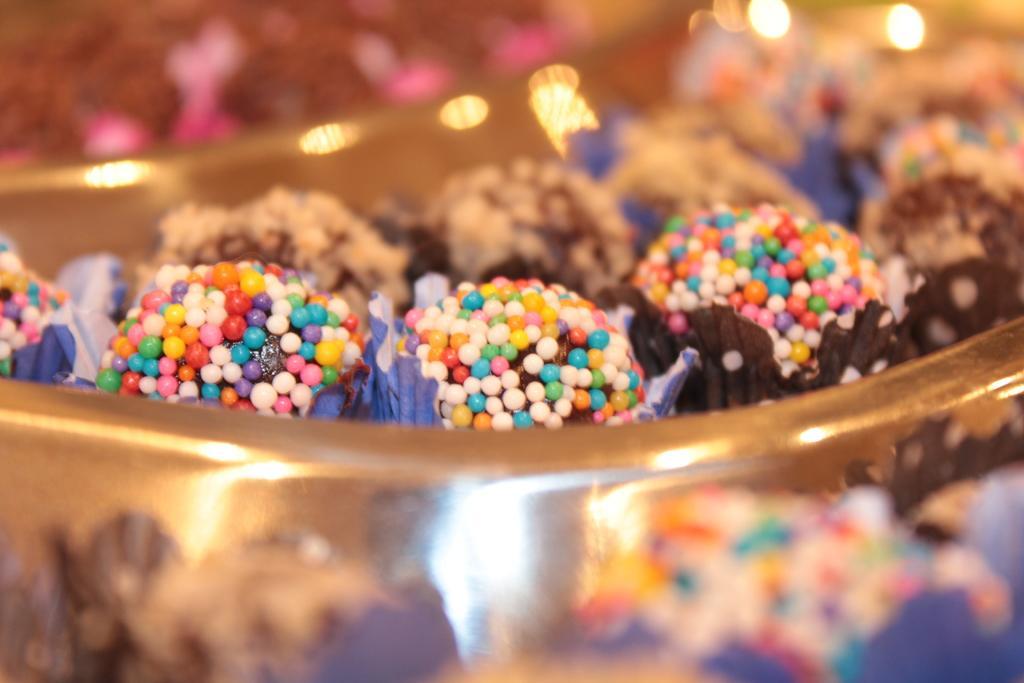Describe this image in one or two sentences. In this image we can see a bowl containing desserts. 